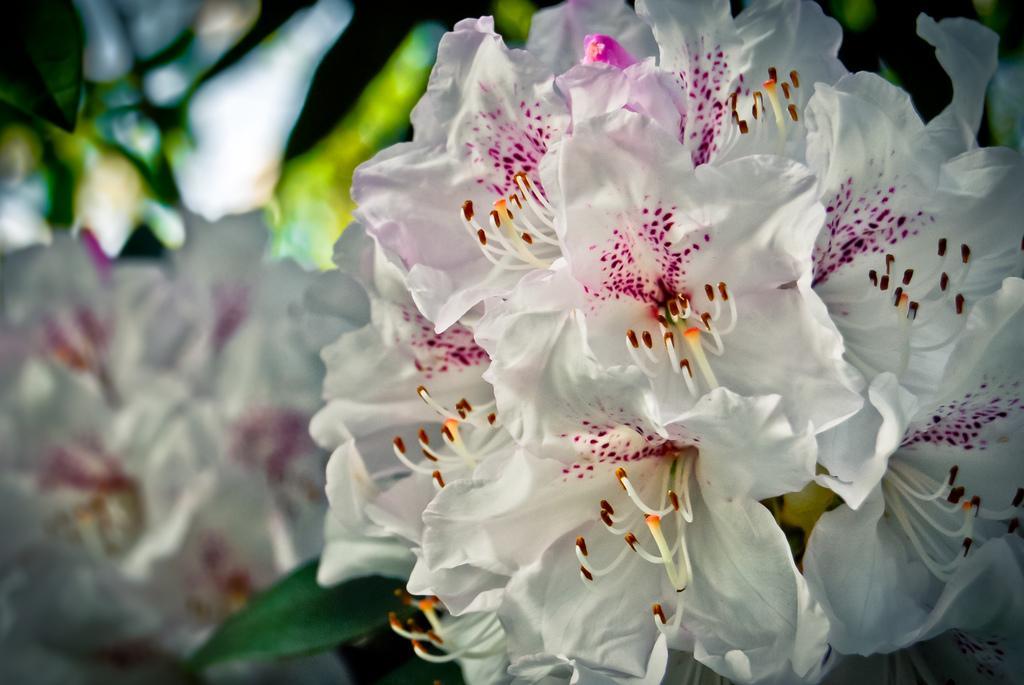How would you summarize this image in a sentence or two? This image consists of flowers which are in white color. In the background, it is green in color and it is blurred in the background. 